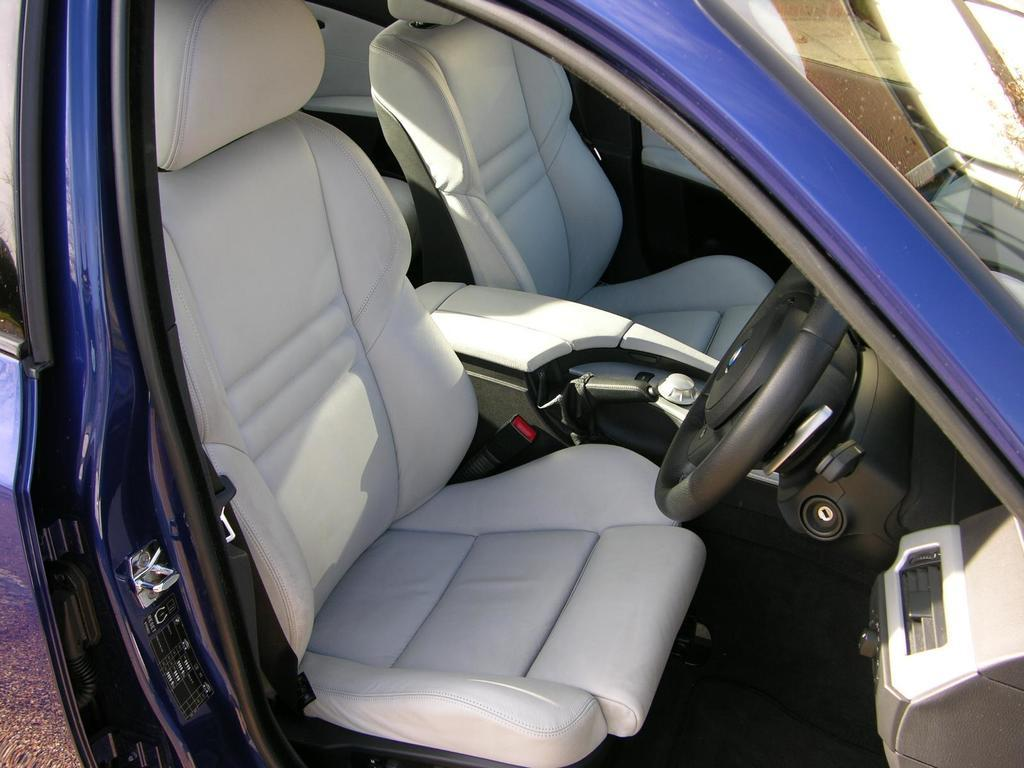What is the main subject of the image? The main subject of the image is a car. Can you describe the car's appearance? The car is blue in color. What can be found inside the car? There are seats inside the car. What is used to control the car's direction? There is a steering wheel in the car. How many crates are stacked on top of the car in the image? There are no crates present in the image; the car is the main subject. What type of lead is connected to the car in the image? There is no lead connected to the car in the image. 